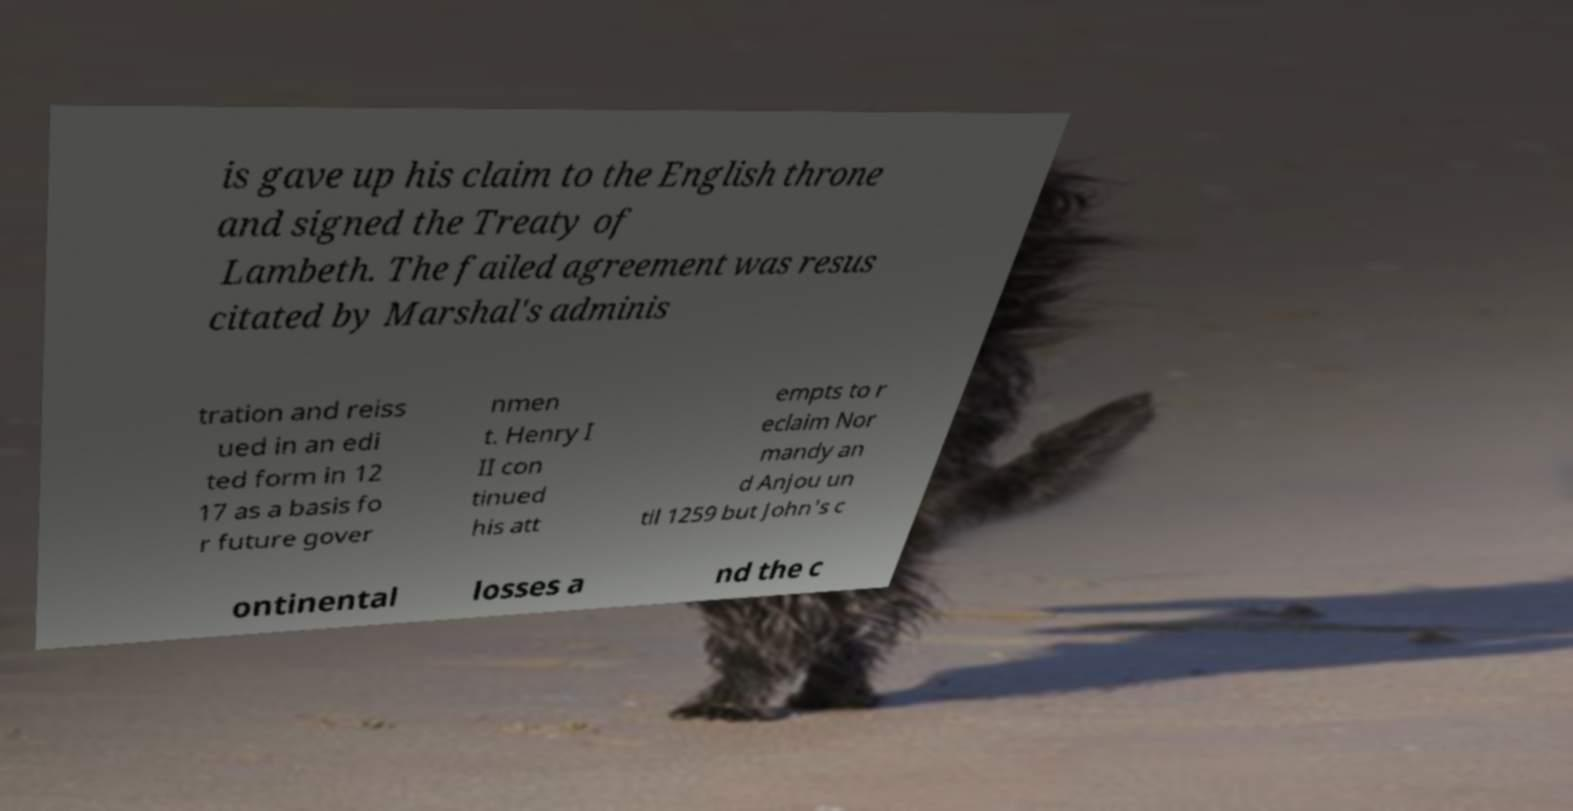What messages or text are displayed in this image? I need them in a readable, typed format. is gave up his claim to the English throne and signed the Treaty of Lambeth. The failed agreement was resus citated by Marshal's adminis tration and reiss ued in an edi ted form in 12 17 as a basis fo r future gover nmen t. Henry I II con tinued his att empts to r eclaim Nor mandy an d Anjou un til 1259 but John's c ontinental losses a nd the c 